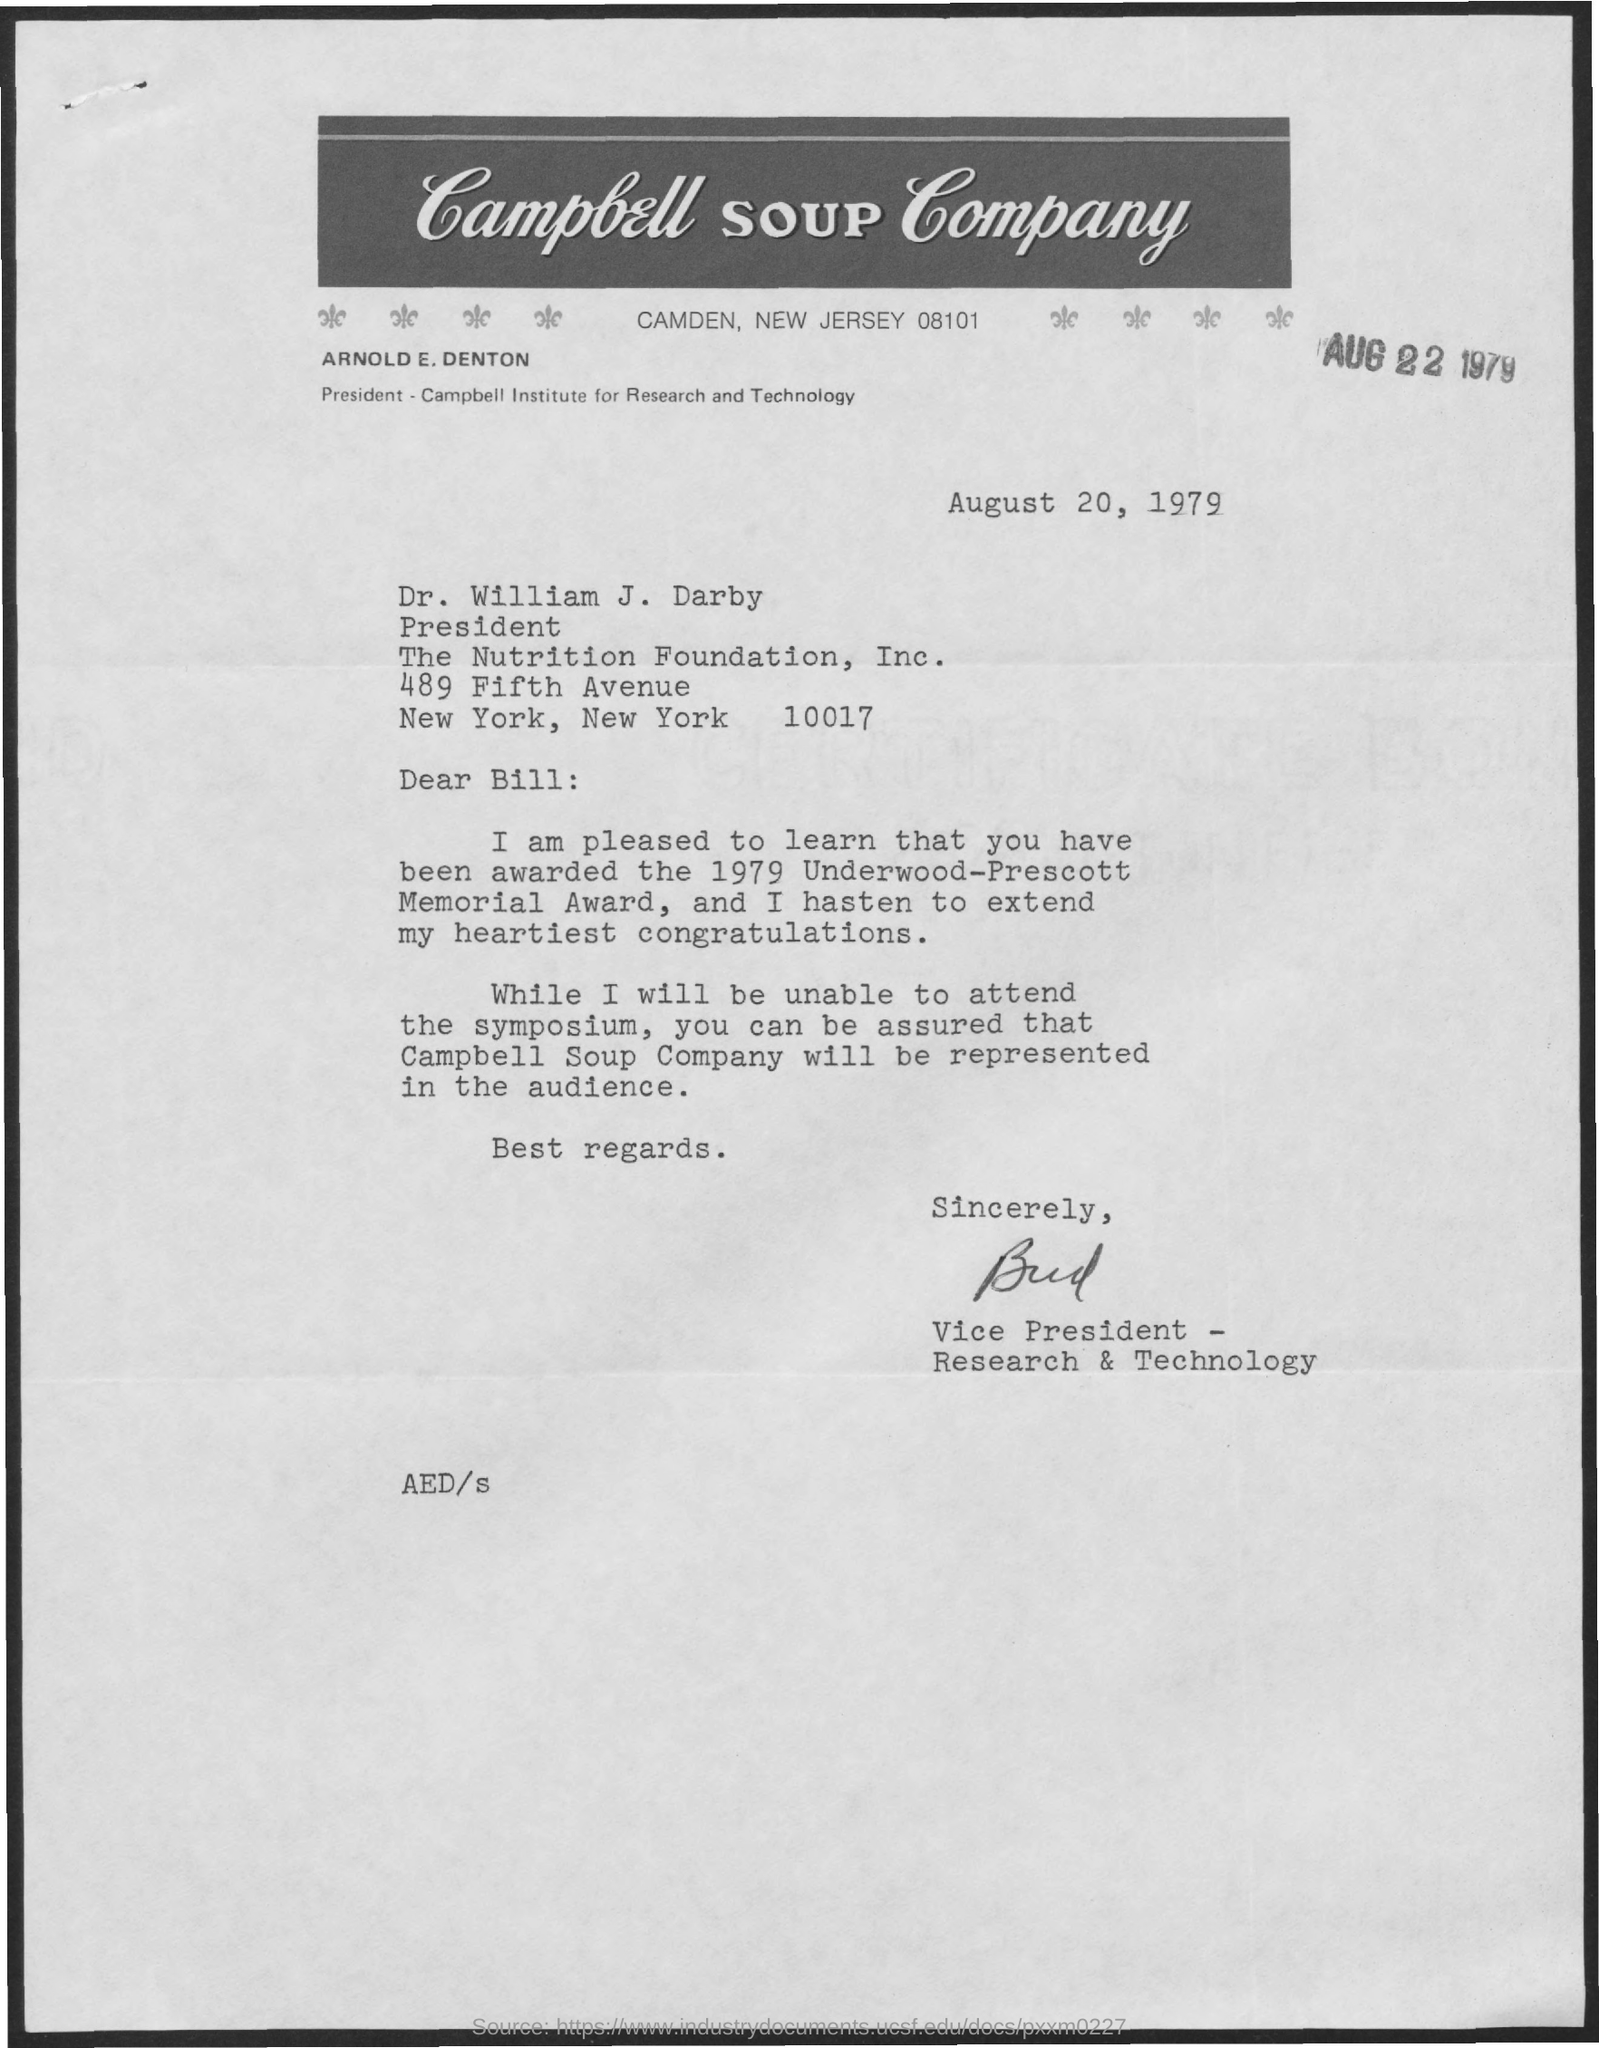Mention a couple of crucial points in this snapshot. Arnold E. Denton is the president of the Campbell Institute for Research and Technology. Dr. William J. Darby was awarded the 1979 Underwood-Prescott Memorial Award. The addressee of this letter is Dr. William J. Darby. Campbell Soup Company is mentioned in the letter head. Dr. William J. Darby is the designated President of The Nutrition Foundation, Inc. 